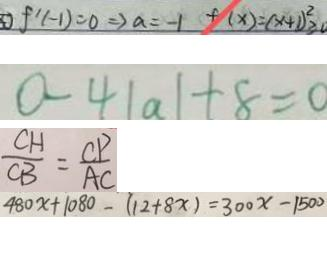<formula> <loc_0><loc_0><loc_500><loc_500>f ^ { \prime } ( - 1 ) = 0 \Rightarrow a = - 1 f ( x ) = ( x + 1 ) ^ { 2 } \geq 0 
 0 - 4 \vert a \vert + 8 = 0 
 \frac { C H } { C B } = \frac { C P } { A C } 
 4 8 0 x + 1 0 8 0 - ( 1 2 + 8 x ) = 3 0 0 x - 1 5 0 0</formula> 